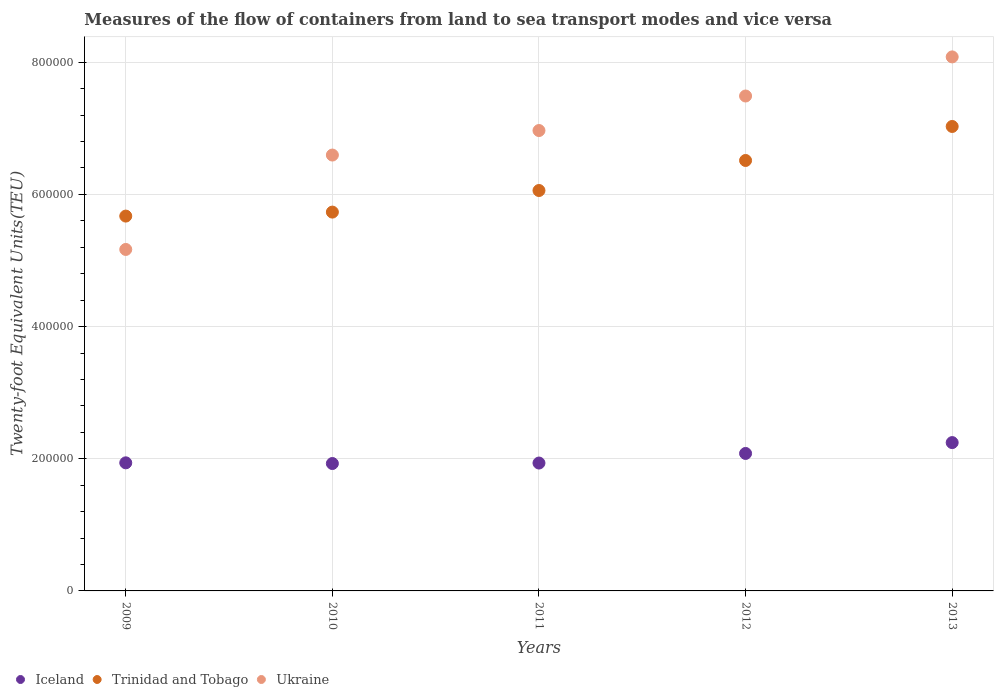How many different coloured dotlines are there?
Make the answer very short. 3. What is the container port traffic in Trinidad and Tobago in 2012?
Keep it short and to the point. 6.51e+05. Across all years, what is the maximum container port traffic in Trinidad and Tobago?
Make the answer very short. 7.03e+05. Across all years, what is the minimum container port traffic in Iceland?
Keep it short and to the point. 1.93e+05. In which year was the container port traffic in Trinidad and Tobago minimum?
Offer a terse response. 2009. What is the total container port traffic in Ukraine in the graph?
Provide a short and direct response. 3.43e+06. What is the difference between the container port traffic in Iceland in 2011 and that in 2012?
Your answer should be very brief. -1.45e+04. What is the difference between the container port traffic in Ukraine in 2009 and the container port traffic in Trinidad and Tobago in 2010?
Make the answer very short. -5.65e+04. What is the average container port traffic in Trinidad and Tobago per year?
Keep it short and to the point. 6.20e+05. In the year 2013, what is the difference between the container port traffic in Trinidad and Tobago and container port traffic in Iceland?
Provide a succinct answer. 4.78e+05. What is the ratio of the container port traffic in Iceland in 2009 to that in 2012?
Provide a short and direct response. 0.93. Is the container port traffic in Iceland in 2010 less than that in 2013?
Ensure brevity in your answer.  Yes. What is the difference between the highest and the second highest container port traffic in Iceland?
Your answer should be very brief. 1.64e+04. What is the difference between the highest and the lowest container port traffic in Iceland?
Your response must be concise. 3.17e+04. In how many years, is the container port traffic in Trinidad and Tobago greater than the average container port traffic in Trinidad and Tobago taken over all years?
Your response must be concise. 2. Is it the case that in every year, the sum of the container port traffic in Iceland and container port traffic in Ukraine  is greater than the container port traffic in Trinidad and Tobago?
Your answer should be very brief. Yes. Is the container port traffic in Ukraine strictly greater than the container port traffic in Iceland over the years?
Make the answer very short. Yes. Is the container port traffic in Ukraine strictly less than the container port traffic in Trinidad and Tobago over the years?
Your answer should be very brief. No. How many dotlines are there?
Offer a very short reply. 3. How many years are there in the graph?
Provide a succinct answer. 5. What is the difference between two consecutive major ticks on the Y-axis?
Ensure brevity in your answer.  2.00e+05. How many legend labels are there?
Offer a terse response. 3. What is the title of the graph?
Your response must be concise. Measures of the flow of containers from land to sea transport modes and vice versa. Does "Monaco" appear as one of the legend labels in the graph?
Your response must be concise. No. What is the label or title of the X-axis?
Keep it short and to the point. Years. What is the label or title of the Y-axis?
Make the answer very short. Twenty-foot Equivalent Units(TEU). What is the Twenty-foot Equivalent Units(TEU) of Iceland in 2009?
Keep it short and to the point. 1.94e+05. What is the Twenty-foot Equivalent Units(TEU) of Trinidad and Tobago in 2009?
Keep it short and to the point. 5.67e+05. What is the Twenty-foot Equivalent Units(TEU) of Ukraine in 2009?
Offer a very short reply. 5.17e+05. What is the Twenty-foot Equivalent Units(TEU) in Iceland in 2010?
Your response must be concise. 1.93e+05. What is the Twenty-foot Equivalent Units(TEU) of Trinidad and Tobago in 2010?
Give a very brief answer. 5.73e+05. What is the Twenty-foot Equivalent Units(TEU) in Ukraine in 2010?
Provide a short and direct response. 6.60e+05. What is the Twenty-foot Equivalent Units(TEU) of Iceland in 2011?
Offer a terse response. 1.94e+05. What is the Twenty-foot Equivalent Units(TEU) in Trinidad and Tobago in 2011?
Give a very brief answer. 6.06e+05. What is the Twenty-foot Equivalent Units(TEU) in Ukraine in 2011?
Make the answer very short. 6.97e+05. What is the Twenty-foot Equivalent Units(TEU) in Iceland in 2012?
Offer a terse response. 2.08e+05. What is the Twenty-foot Equivalent Units(TEU) of Trinidad and Tobago in 2012?
Ensure brevity in your answer.  6.51e+05. What is the Twenty-foot Equivalent Units(TEU) of Ukraine in 2012?
Give a very brief answer. 7.49e+05. What is the Twenty-foot Equivalent Units(TEU) of Iceland in 2013?
Ensure brevity in your answer.  2.24e+05. What is the Twenty-foot Equivalent Units(TEU) in Trinidad and Tobago in 2013?
Offer a terse response. 7.03e+05. What is the Twenty-foot Equivalent Units(TEU) in Ukraine in 2013?
Your answer should be compact. 8.08e+05. Across all years, what is the maximum Twenty-foot Equivalent Units(TEU) of Iceland?
Make the answer very short. 2.24e+05. Across all years, what is the maximum Twenty-foot Equivalent Units(TEU) in Trinidad and Tobago?
Offer a terse response. 7.03e+05. Across all years, what is the maximum Twenty-foot Equivalent Units(TEU) of Ukraine?
Offer a terse response. 8.08e+05. Across all years, what is the minimum Twenty-foot Equivalent Units(TEU) in Iceland?
Provide a short and direct response. 1.93e+05. Across all years, what is the minimum Twenty-foot Equivalent Units(TEU) in Trinidad and Tobago?
Your answer should be very brief. 5.67e+05. Across all years, what is the minimum Twenty-foot Equivalent Units(TEU) in Ukraine?
Your response must be concise. 5.17e+05. What is the total Twenty-foot Equivalent Units(TEU) in Iceland in the graph?
Keep it short and to the point. 1.01e+06. What is the total Twenty-foot Equivalent Units(TEU) in Trinidad and Tobago in the graph?
Give a very brief answer. 3.10e+06. What is the total Twenty-foot Equivalent Units(TEU) in Ukraine in the graph?
Your response must be concise. 3.43e+06. What is the difference between the Twenty-foot Equivalent Units(TEU) of Iceland in 2009 and that in 2010?
Your answer should be very brief. 1038. What is the difference between the Twenty-foot Equivalent Units(TEU) of Trinidad and Tobago in 2009 and that in 2010?
Your answer should be compact. -6034. What is the difference between the Twenty-foot Equivalent Units(TEU) of Ukraine in 2009 and that in 2010?
Ensure brevity in your answer.  -1.43e+05. What is the difference between the Twenty-foot Equivalent Units(TEU) in Iceland in 2009 and that in 2011?
Ensure brevity in your answer.  316. What is the difference between the Twenty-foot Equivalent Units(TEU) of Trinidad and Tobago in 2009 and that in 2011?
Make the answer very short. -3.87e+04. What is the difference between the Twenty-foot Equivalent Units(TEU) of Ukraine in 2009 and that in 2011?
Your answer should be compact. -1.80e+05. What is the difference between the Twenty-foot Equivalent Units(TEU) in Iceland in 2009 and that in 2012?
Your response must be concise. -1.42e+04. What is the difference between the Twenty-foot Equivalent Units(TEU) of Trinidad and Tobago in 2009 and that in 2012?
Make the answer very short. -8.41e+04. What is the difference between the Twenty-foot Equivalent Units(TEU) of Ukraine in 2009 and that in 2012?
Make the answer very short. -2.32e+05. What is the difference between the Twenty-foot Equivalent Units(TEU) in Iceland in 2009 and that in 2013?
Provide a short and direct response. -3.06e+04. What is the difference between the Twenty-foot Equivalent Units(TEU) in Trinidad and Tobago in 2009 and that in 2013?
Provide a short and direct response. -1.36e+05. What is the difference between the Twenty-foot Equivalent Units(TEU) of Ukraine in 2009 and that in 2013?
Offer a terse response. -2.91e+05. What is the difference between the Twenty-foot Equivalent Units(TEU) in Iceland in 2010 and that in 2011?
Your answer should be very brief. -722. What is the difference between the Twenty-foot Equivalent Units(TEU) in Trinidad and Tobago in 2010 and that in 2011?
Keep it short and to the point. -3.27e+04. What is the difference between the Twenty-foot Equivalent Units(TEU) in Ukraine in 2010 and that in 2011?
Provide a succinct answer. -3.71e+04. What is the difference between the Twenty-foot Equivalent Units(TEU) of Iceland in 2010 and that in 2012?
Ensure brevity in your answer.  -1.52e+04. What is the difference between the Twenty-foot Equivalent Units(TEU) of Trinidad and Tobago in 2010 and that in 2012?
Your answer should be very brief. -7.81e+04. What is the difference between the Twenty-foot Equivalent Units(TEU) of Ukraine in 2010 and that in 2012?
Offer a very short reply. -8.93e+04. What is the difference between the Twenty-foot Equivalent Units(TEU) in Iceland in 2010 and that in 2013?
Keep it short and to the point. -3.17e+04. What is the difference between the Twenty-foot Equivalent Units(TEU) in Trinidad and Tobago in 2010 and that in 2013?
Offer a very short reply. -1.30e+05. What is the difference between the Twenty-foot Equivalent Units(TEU) in Ukraine in 2010 and that in 2013?
Provide a short and direct response. -1.49e+05. What is the difference between the Twenty-foot Equivalent Units(TEU) of Iceland in 2011 and that in 2012?
Provide a short and direct response. -1.45e+04. What is the difference between the Twenty-foot Equivalent Units(TEU) of Trinidad and Tobago in 2011 and that in 2012?
Your answer should be very brief. -4.54e+04. What is the difference between the Twenty-foot Equivalent Units(TEU) of Ukraine in 2011 and that in 2012?
Provide a succinct answer. -5.22e+04. What is the difference between the Twenty-foot Equivalent Units(TEU) in Iceland in 2011 and that in 2013?
Provide a succinct answer. -3.09e+04. What is the difference between the Twenty-foot Equivalent Units(TEU) of Trinidad and Tobago in 2011 and that in 2013?
Ensure brevity in your answer.  -9.69e+04. What is the difference between the Twenty-foot Equivalent Units(TEU) in Ukraine in 2011 and that in 2013?
Your response must be concise. -1.11e+05. What is the difference between the Twenty-foot Equivalent Units(TEU) of Iceland in 2012 and that in 2013?
Make the answer very short. -1.64e+04. What is the difference between the Twenty-foot Equivalent Units(TEU) of Trinidad and Tobago in 2012 and that in 2013?
Offer a terse response. -5.15e+04. What is the difference between the Twenty-foot Equivalent Units(TEU) in Ukraine in 2012 and that in 2013?
Your answer should be compact. -5.92e+04. What is the difference between the Twenty-foot Equivalent Units(TEU) in Iceland in 2009 and the Twenty-foot Equivalent Units(TEU) in Trinidad and Tobago in 2010?
Keep it short and to the point. -3.79e+05. What is the difference between the Twenty-foot Equivalent Units(TEU) of Iceland in 2009 and the Twenty-foot Equivalent Units(TEU) of Ukraine in 2010?
Keep it short and to the point. -4.66e+05. What is the difference between the Twenty-foot Equivalent Units(TEU) in Trinidad and Tobago in 2009 and the Twenty-foot Equivalent Units(TEU) in Ukraine in 2010?
Give a very brief answer. -9.24e+04. What is the difference between the Twenty-foot Equivalent Units(TEU) in Iceland in 2009 and the Twenty-foot Equivalent Units(TEU) in Trinidad and Tobago in 2011?
Provide a short and direct response. -4.12e+05. What is the difference between the Twenty-foot Equivalent Units(TEU) in Iceland in 2009 and the Twenty-foot Equivalent Units(TEU) in Ukraine in 2011?
Keep it short and to the point. -5.03e+05. What is the difference between the Twenty-foot Equivalent Units(TEU) in Trinidad and Tobago in 2009 and the Twenty-foot Equivalent Units(TEU) in Ukraine in 2011?
Your response must be concise. -1.29e+05. What is the difference between the Twenty-foot Equivalent Units(TEU) of Iceland in 2009 and the Twenty-foot Equivalent Units(TEU) of Trinidad and Tobago in 2012?
Offer a very short reply. -4.58e+05. What is the difference between the Twenty-foot Equivalent Units(TEU) in Iceland in 2009 and the Twenty-foot Equivalent Units(TEU) in Ukraine in 2012?
Ensure brevity in your answer.  -5.55e+05. What is the difference between the Twenty-foot Equivalent Units(TEU) in Trinidad and Tobago in 2009 and the Twenty-foot Equivalent Units(TEU) in Ukraine in 2012?
Make the answer very short. -1.82e+05. What is the difference between the Twenty-foot Equivalent Units(TEU) of Iceland in 2009 and the Twenty-foot Equivalent Units(TEU) of Trinidad and Tobago in 2013?
Your answer should be compact. -5.09e+05. What is the difference between the Twenty-foot Equivalent Units(TEU) in Iceland in 2009 and the Twenty-foot Equivalent Units(TEU) in Ukraine in 2013?
Your answer should be compact. -6.14e+05. What is the difference between the Twenty-foot Equivalent Units(TEU) of Trinidad and Tobago in 2009 and the Twenty-foot Equivalent Units(TEU) of Ukraine in 2013?
Provide a short and direct response. -2.41e+05. What is the difference between the Twenty-foot Equivalent Units(TEU) in Iceland in 2010 and the Twenty-foot Equivalent Units(TEU) in Trinidad and Tobago in 2011?
Your response must be concise. -4.13e+05. What is the difference between the Twenty-foot Equivalent Units(TEU) in Iceland in 2010 and the Twenty-foot Equivalent Units(TEU) in Ukraine in 2011?
Ensure brevity in your answer.  -5.04e+05. What is the difference between the Twenty-foot Equivalent Units(TEU) of Trinidad and Tobago in 2010 and the Twenty-foot Equivalent Units(TEU) of Ukraine in 2011?
Keep it short and to the point. -1.23e+05. What is the difference between the Twenty-foot Equivalent Units(TEU) in Iceland in 2010 and the Twenty-foot Equivalent Units(TEU) in Trinidad and Tobago in 2012?
Keep it short and to the point. -4.59e+05. What is the difference between the Twenty-foot Equivalent Units(TEU) in Iceland in 2010 and the Twenty-foot Equivalent Units(TEU) in Ukraine in 2012?
Offer a terse response. -5.56e+05. What is the difference between the Twenty-foot Equivalent Units(TEU) of Trinidad and Tobago in 2010 and the Twenty-foot Equivalent Units(TEU) of Ukraine in 2012?
Keep it short and to the point. -1.76e+05. What is the difference between the Twenty-foot Equivalent Units(TEU) of Iceland in 2010 and the Twenty-foot Equivalent Units(TEU) of Trinidad and Tobago in 2013?
Offer a terse response. -5.10e+05. What is the difference between the Twenty-foot Equivalent Units(TEU) of Iceland in 2010 and the Twenty-foot Equivalent Units(TEU) of Ukraine in 2013?
Your response must be concise. -6.15e+05. What is the difference between the Twenty-foot Equivalent Units(TEU) in Trinidad and Tobago in 2010 and the Twenty-foot Equivalent Units(TEU) in Ukraine in 2013?
Your answer should be compact. -2.35e+05. What is the difference between the Twenty-foot Equivalent Units(TEU) in Iceland in 2011 and the Twenty-foot Equivalent Units(TEU) in Trinidad and Tobago in 2012?
Ensure brevity in your answer.  -4.58e+05. What is the difference between the Twenty-foot Equivalent Units(TEU) in Iceland in 2011 and the Twenty-foot Equivalent Units(TEU) in Ukraine in 2012?
Ensure brevity in your answer.  -5.55e+05. What is the difference between the Twenty-foot Equivalent Units(TEU) in Trinidad and Tobago in 2011 and the Twenty-foot Equivalent Units(TEU) in Ukraine in 2012?
Offer a terse response. -1.43e+05. What is the difference between the Twenty-foot Equivalent Units(TEU) of Iceland in 2011 and the Twenty-foot Equivalent Units(TEU) of Trinidad and Tobago in 2013?
Your answer should be compact. -5.09e+05. What is the difference between the Twenty-foot Equivalent Units(TEU) in Iceland in 2011 and the Twenty-foot Equivalent Units(TEU) in Ukraine in 2013?
Offer a terse response. -6.15e+05. What is the difference between the Twenty-foot Equivalent Units(TEU) in Trinidad and Tobago in 2011 and the Twenty-foot Equivalent Units(TEU) in Ukraine in 2013?
Ensure brevity in your answer.  -2.02e+05. What is the difference between the Twenty-foot Equivalent Units(TEU) of Iceland in 2012 and the Twenty-foot Equivalent Units(TEU) of Trinidad and Tobago in 2013?
Your answer should be very brief. -4.95e+05. What is the difference between the Twenty-foot Equivalent Units(TEU) in Iceland in 2012 and the Twenty-foot Equivalent Units(TEU) in Ukraine in 2013?
Provide a succinct answer. -6.00e+05. What is the difference between the Twenty-foot Equivalent Units(TEU) of Trinidad and Tobago in 2012 and the Twenty-foot Equivalent Units(TEU) of Ukraine in 2013?
Give a very brief answer. -1.57e+05. What is the average Twenty-foot Equivalent Units(TEU) of Iceland per year?
Your answer should be compact. 2.03e+05. What is the average Twenty-foot Equivalent Units(TEU) in Trinidad and Tobago per year?
Make the answer very short. 6.20e+05. What is the average Twenty-foot Equivalent Units(TEU) in Ukraine per year?
Give a very brief answer. 6.86e+05. In the year 2009, what is the difference between the Twenty-foot Equivalent Units(TEU) in Iceland and Twenty-foot Equivalent Units(TEU) in Trinidad and Tobago?
Make the answer very short. -3.73e+05. In the year 2009, what is the difference between the Twenty-foot Equivalent Units(TEU) of Iceland and Twenty-foot Equivalent Units(TEU) of Ukraine?
Your answer should be compact. -3.23e+05. In the year 2009, what is the difference between the Twenty-foot Equivalent Units(TEU) in Trinidad and Tobago and Twenty-foot Equivalent Units(TEU) in Ukraine?
Make the answer very short. 5.05e+04. In the year 2010, what is the difference between the Twenty-foot Equivalent Units(TEU) in Iceland and Twenty-foot Equivalent Units(TEU) in Trinidad and Tobago?
Provide a succinct answer. -3.80e+05. In the year 2010, what is the difference between the Twenty-foot Equivalent Units(TEU) of Iceland and Twenty-foot Equivalent Units(TEU) of Ukraine?
Offer a very short reply. -4.67e+05. In the year 2010, what is the difference between the Twenty-foot Equivalent Units(TEU) of Trinidad and Tobago and Twenty-foot Equivalent Units(TEU) of Ukraine?
Offer a very short reply. -8.63e+04. In the year 2011, what is the difference between the Twenty-foot Equivalent Units(TEU) in Iceland and Twenty-foot Equivalent Units(TEU) in Trinidad and Tobago?
Ensure brevity in your answer.  -4.12e+05. In the year 2011, what is the difference between the Twenty-foot Equivalent Units(TEU) in Iceland and Twenty-foot Equivalent Units(TEU) in Ukraine?
Your answer should be compact. -5.03e+05. In the year 2011, what is the difference between the Twenty-foot Equivalent Units(TEU) of Trinidad and Tobago and Twenty-foot Equivalent Units(TEU) of Ukraine?
Offer a terse response. -9.08e+04. In the year 2012, what is the difference between the Twenty-foot Equivalent Units(TEU) of Iceland and Twenty-foot Equivalent Units(TEU) of Trinidad and Tobago?
Offer a terse response. -4.43e+05. In the year 2012, what is the difference between the Twenty-foot Equivalent Units(TEU) in Iceland and Twenty-foot Equivalent Units(TEU) in Ukraine?
Your answer should be very brief. -5.41e+05. In the year 2012, what is the difference between the Twenty-foot Equivalent Units(TEU) in Trinidad and Tobago and Twenty-foot Equivalent Units(TEU) in Ukraine?
Provide a short and direct response. -9.76e+04. In the year 2013, what is the difference between the Twenty-foot Equivalent Units(TEU) in Iceland and Twenty-foot Equivalent Units(TEU) in Trinidad and Tobago?
Give a very brief answer. -4.78e+05. In the year 2013, what is the difference between the Twenty-foot Equivalent Units(TEU) in Iceland and Twenty-foot Equivalent Units(TEU) in Ukraine?
Offer a terse response. -5.84e+05. In the year 2013, what is the difference between the Twenty-foot Equivalent Units(TEU) of Trinidad and Tobago and Twenty-foot Equivalent Units(TEU) of Ukraine?
Your answer should be compact. -1.05e+05. What is the ratio of the Twenty-foot Equivalent Units(TEU) in Iceland in 2009 to that in 2010?
Give a very brief answer. 1.01. What is the ratio of the Twenty-foot Equivalent Units(TEU) in Trinidad and Tobago in 2009 to that in 2010?
Give a very brief answer. 0.99. What is the ratio of the Twenty-foot Equivalent Units(TEU) in Ukraine in 2009 to that in 2010?
Make the answer very short. 0.78. What is the ratio of the Twenty-foot Equivalent Units(TEU) of Trinidad and Tobago in 2009 to that in 2011?
Offer a very short reply. 0.94. What is the ratio of the Twenty-foot Equivalent Units(TEU) of Ukraine in 2009 to that in 2011?
Provide a short and direct response. 0.74. What is the ratio of the Twenty-foot Equivalent Units(TEU) of Iceland in 2009 to that in 2012?
Your answer should be very brief. 0.93. What is the ratio of the Twenty-foot Equivalent Units(TEU) in Trinidad and Tobago in 2009 to that in 2012?
Offer a very short reply. 0.87. What is the ratio of the Twenty-foot Equivalent Units(TEU) of Ukraine in 2009 to that in 2012?
Ensure brevity in your answer.  0.69. What is the ratio of the Twenty-foot Equivalent Units(TEU) of Iceland in 2009 to that in 2013?
Give a very brief answer. 0.86. What is the ratio of the Twenty-foot Equivalent Units(TEU) of Trinidad and Tobago in 2009 to that in 2013?
Your answer should be compact. 0.81. What is the ratio of the Twenty-foot Equivalent Units(TEU) of Ukraine in 2009 to that in 2013?
Offer a terse response. 0.64. What is the ratio of the Twenty-foot Equivalent Units(TEU) in Iceland in 2010 to that in 2011?
Your answer should be compact. 1. What is the ratio of the Twenty-foot Equivalent Units(TEU) in Trinidad and Tobago in 2010 to that in 2011?
Ensure brevity in your answer.  0.95. What is the ratio of the Twenty-foot Equivalent Units(TEU) of Ukraine in 2010 to that in 2011?
Provide a succinct answer. 0.95. What is the ratio of the Twenty-foot Equivalent Units(TEU) in Iceland in 2010 to that in 2012?
Offer a very short reply. 0.93. What is the ratio of the Twenty-foot Equivalent Units(TEU) of Trinidad and Tobago in 2010 to that in 2012?
Provide a succinct answer. 0.88. What is the ratio of the Twenty-foot Equivalent Units(TEU) of Ukraine in 2010 to that in 2012?
Offer a terse response. 0.88. What is the ratio of the Twenty-foot Equivalent Units(TEU) of Iceland in 2010 to that in 2013?
Provide a short and direct response. 0.86. What is the ratio of the Twenty-foot Equivalent Units(TEU) of Trinidad and Tobago in 2010 to that in 2013?
Provide a short and direct response. 0.82. What is the ratio of the Twenty-foot Equivalent Units(TEU) of Ukraine in 2010 to that in 2013?
Your answer should be very brief. 0.82. What is the ratio of the Twenty-foot Equivalent Units(TEU) of Iceland in 2011 to that in 2012?
Provide a succinct answer. 0.93. What is the ratio of the Twenty-foot Equivalent Units(TEU) of Trinidad and Tobago in 2011 to that in 2012?
Provide a short and direct response. 0.93. What is the ratio of the Twenty-foot Equivalent Units(TEU) in Ukraine in 2011 to that in 2012?
Offer a very short reply. 0.93. What is the ratio of the Twenty-foot Equivalent Units(TEU) in Iceland in 2011 to that in 2013?
Make the answer very short. 0.86. What is the ratio of the Twenty-foot Equivalent Units(TEU) in Trinidad and Tobago in 2011 to that in 2013?
Keep it short and to the point. 0.86. What is the ratio of the Twenty-foot Equivalent Units(TEU) of Ukraine in 2011 to that in 2013?
Offer a very short reply. 0.86. What is the ratio of the Twenty-foot Equivalent Units(TEU) in Iceland in 2012 to that in 2013?
Your answer should be very brief. 0.93. What is the ratio of the Twenty-foot Equivalent Units(TEU) of Trinidad and Tobago in 2012 to that in 2013?
Offer a very short reply. 0.93. What is the ratio of the Twenty-foot Equivalent Units(TEU) in Ukraine in 2012 to that in 2013?
Offer a terse response. 0.93. What is the difference between the highest and the second highest Twenty-foot Equivalent Units(TEU) of Iceland?
Make the answer very short. 1.64e+04. What is the difference between the highest and the second highest Twenty-foot Equivalent Units(TEU) in Trinidad and Tobago?
Offer a terse response. 5.15e+04. What is the difference between the highest and the second highest Twenty-foot Equivalent Units(TEU) of Ukraine?
Give a very brief answer. 5.92e+04. What is the difference between the highest and the lowest Twenty-foot Equivalent Units(TEU) of Iceland?
Ensure brevity in your answer.  3.17e+04. What is the difference between the highest and the lowest Twenty-foot Equivalent Units(TEU) in Trinidad and Tobago?
Your answer should be compact. 1.36e+05. What is the difference between the highest and the lowest Twenty-foot Equivalent Units(TEU) of Ukraine?
Give a very brief answer. 2.91e+05. 